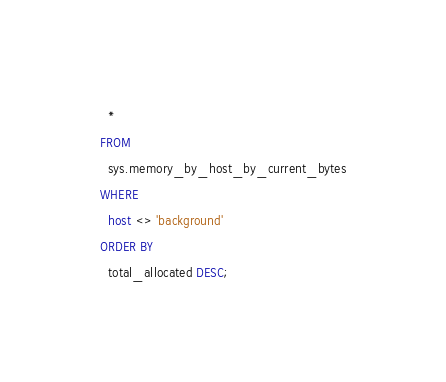<code> <loc_0><loc_0><loc_500><loc_500><_SQL_>  *
FROM
  sys.memory_by_host_by_current_bytes
WHERE
  host <> 'background'
ORDER BY
  total_allocated DESC;
</code> 